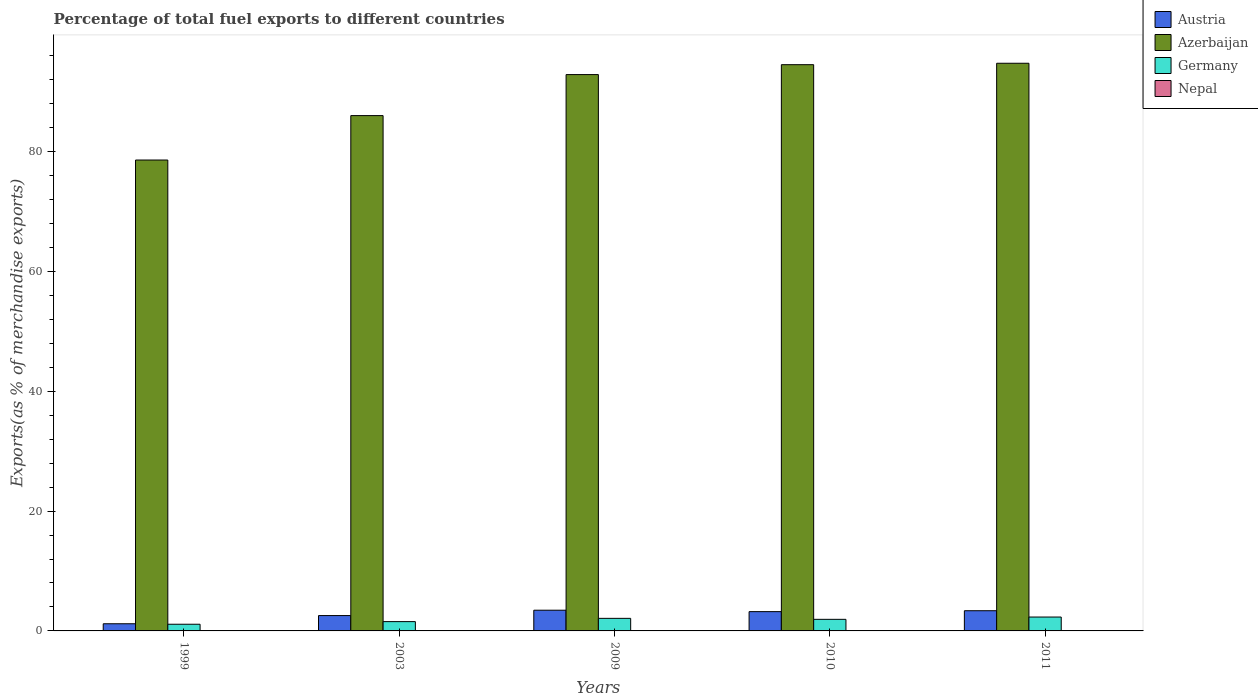Are the number of bars on each tick of the X-axis equal?
Provide a short and direct response. Yes. How many bars are there on the 3rd tick from the left?
Your answer should be compact. 4. How many bars are there on the 4th tick from the right?
Provide a short and direct response. 4. What is the label of the 5th group of bars from the left?
Give a very brief answer. 2011. What is the percentage of exports to different countries in Nepal in 2009?
Offer a very short reply. 0. Across all years, what is the maximum percentage of exports to different countries in Azerbaijan?
Your answer should be very brief. 94.75. Across all years, what is the minimum percentage of exports to different countries in Germany?
Keep it short and to the point. 1.12. In which year was the percentage of exports to different countries in Germany minimum?
Ensure brevity in your answer.  1999. What is the total percentage of exports to different countries in Germany in the graph?
Your answer should be compact. 9.02. What is the difference between the percentage of exports to different countries in Austria in 2003 and that in 2009?
Make the answer very short. -0.89. What is the difference between the percentage of exports to different countries in Germany in 2011 and the percentage of exports to different countries in Azerbaijan in 1999?
Offer a terse response. -76.28. What is the average percentage of exports to different countries in Germany per year?
Provide a succinct answer. 1.8. In the year 2003, what is the difference between the percentage of exports to different countries in Nepal and percentage of exports to different countries in Austria?
Keep it short and to the point. -2.56. In how many years, is the percentage of exports to different countries in Nepal greater than 32 %?
Your answer should be compact. 0. What is the ratio of the percentage of exports to different countries in Nepal in 2003 to that in 2011?
Provide a succinct answer. 690.53. Is the percentage of exports to different countries in Germany in 2009 less than that in 2010?
Provide a short and direct response. No. What is the difference between the highest and the second highest percentage of exports to different countries in Austria?
Your response must be concise. 0.09. What is the difference between the highest and the lowest percentage of exports to different countries in Austria?
Ensure brevity in your answer.  2.26. Is it the case that in every year, the sum of the percentage of exports to different countries in Austria and percentage of exports to different countries in Germany is greater than the sum of percentage of exports to different countries in Nepal and percentage of exports to different countries in Azerbaijan?
Make the answer very short. No. What does the 1st bar from the left in 1999 represents?
Give a very brief answer. Austria. How many years are there in the graph?
Provide a short and direct response. 5. What is the difference between two consecutive major ticks on the Y-axis?
Your answer should be compact. 20. Are the values on the major ticks of Y-axis written in scientific E-notation?
Provide a short and direct response. No. Where does the legend appear in the graph?
Offer a terse response. Top right. How are the legend labels stacked?
Keep it short and to the point. Vertical. What is the title of the graph?
Keep it short and to the point. Percentage of total fuel exports to different countries. What is the label or title of the Y-axis?
Your answer should be compact. Exports(as % of merchandise exports). What is the Exports(as % of merchandise exports) of Austria in 1999?
Ensure brevity in your answer.  1.19. What is the Exports(as % of merchandise exports) of Azerbaijan in 1999?
Offer a terse response. 78.6. What is the Exports(as % of merchandise exports) of Germany in 1999?
Your answer should be compact. 1.12. What is the Exports(as % of merchandise exports) of Nepal in 1999?
Your response must be concise. 0. What is the Exports(as % of merchandise exports) of Austria in 2003?
Keep it short and to the point. 2.56. What is the Exports(as % of merchandise exports) in Azerbaijan in 2003?
Your response must be concise. 86.01. What is the Exports(as % of merchandise exports) in Germany in 2003?
Your answer should be compact. 1.55. What is the Exports(as % of merchandise exports) of Nepal in 2003?
Give a very brief answer. 0. What is the Exports(as % of merchandise exports) in Austria in 2009?
Your answer should be very brief. 3.46. What is the Exports(as % of merchandise exports) in Azerbaijan in 2009?
Your answer should be very brief. 92.86. What is the Exports(as % of merchandise exports) of Germany in 2009?
Offer a terse response. 2.1. What is the Exports(as % of merchandise exports) in Nepal in 2009?
Your answer should be compact. 0. What is the Exports(as % of merchandise exports) in Austria in 2010?
Your response must be concise. 3.22. What is the Exports(as % of merchandise exports) in Azerbaijan in 2010?
Ensure brevity in your answer.  94.51. What is the Exports(as % of merchandise exports) of Germany in 2010?
Ensure brevity in your answer.  1.93. What is the Exports(as % of merchandise exports) of Nepal in 2010?
Keep it short and to the point. 4.5184108995034e-5. What is the Exports(as % of merchandise exports) of Austria in 2011?
Your answer should be very brief. 3.37. What is the Exports(as % of merchandise exports) of Azerbaijan in 2011?
Offer a very short reply. 94.75. What is the Exports(as % of merchandise exports) of Germany in 2011?
Give a very brief answer. 2.32. What is the Exports(as % of merchandise exports) in Nepal in 2011?
Your response must be concise. 5.17830048737702e-6. Across all years, what is the maximum Exports(as % of merchandise exports) of Austria?
Keep it short and to the point. 3.46. Across all years, what is the maximum Exports(as % of merchandise exports) in Azerbaijan?
Keep it short and to the point. 94.75. Across all years, what is the maximum Exports(as % of merchandise exports) in Germany?
Offer a terse response. 2.32. Across all years, what is the maximum Exports(as % of merchandise exports) of Nepal?
Offer a very short reply. 0. Across all years, what is the minimum Exports(as % of merchandise exports) in Austria?
Your answer should be very brief. 1.19. Across all years, what is the minimum Exports(as % of merchandise exports) in Azerbaijan?
Provide a short and direct response. 78.6. Across all years, what is the minimum Exports(as % of merchandise exports) in Germany?
Your answer should be very brief. 1.12. Across all years, what is the minimum Exports(as % of merchandise exports) of Nepal?
Make the answer very short. 5.17830048737702e-6. What is the total Exports(as % of merchandise exports) in Austria in the graph?
Your answer should be very brief. 13.8. What is the total Exports(as % of merchandise exports) of Azerbaijan in the graph?
Give a very brief answer. 446.72. What is the total Exports(as % of merchandise exports) of Germany in the graph?
Your answer should be very brief. 9.02. What is the total Exports(as % of merchandise exports) in Nepal in the graph?
Your answer should be compact. 0.01. What is the difference between the Exports(as % of merchandise exports) in Austria in 1999 and that in 2003?
Offer a terse response. -1.37. What is the difference between the Exports(as % of merchandise exports) in Azerbaijan in 1999 and that in 2003?
Your answer should be very brief. -7.41. What is the difference between the Exports(as % of merchandise exports) of Germany in 1999 and that in 2003?
Offer a terse response. -0.44. What is the difference between the Exports(as % of merchandise exports) of Nepal in 1999 and that in 2003?
Your answer should be very brief. -0. What is the difference between the Exports(as % of merchandise exports) in Austria in 1999 and that in 2009?
Your answer should be compact. -2.26. What is the difference between the Exports(as % of merchandise exports) of Azerbaijan in 1999 and that in 2009?
Offer a terse response. -14.26. What is the difference between the Exports(as % of merchandise exports) in Germany in 1999 and that in 2009?
Provide a succinct answer. -0.98. What is the difference between the Exports(as % of merchandise exports) of Austria in 1999 and that in 2010?
Offer a very short reply. -2.02. What is the difference between the Exports(as % of merchandise exports) in Azerbaijan in 1999 and that in 2010?
Your response must be concise. -15.91. What is the difference between the Exports(as % of merchandise exports) in Germany in 1999 and that in 2010?
Ensure brevity in your answer.  -0.82. What is the difference between the Exports(as % of merchandise exports) of Nepal in 1999 and that in 2010?
Provide a succinct answer. 0. What is the difference between the Exports(as % of merchandise exports) in Austria in 1999 and that in 2011?
Your response must be concise. -2.18. What is the difference between the Exports(as % of merchandise exports) in Azerbaijan in 1999 and that in 2011?
Offer a very short reply. -16.15. What is the difference between the Exports(as % of merchandise exports) in Germany in 1999 and that in 2011?
Provide a short and direct response. -1.2. What is the difference between the Exports(as % of merchandise exports) in Nepal in 1999 and that in 2011?
Your answer should be compact. 0. What is the difference between the Exports(as % of merchandise exports) in Austria in 2003 and that in 2009?
Provide a short and direct response. -0.89. What is the difference between the Exports(as % of merchandise exports) in Azerbaijan in 2003 and that in 2009?
Provide a short and direct response. -6.85. What is the difference between the Exports(as % of merchandise exports) in Germany in 2003 and that in 2009?
Give a very brief answer. -0.54. What is the difference between the Exports(as % of merchandise exports) of Nepal in 2003 and that in 2009?
Make the answer very short. 0. What is the difference between the Exports(as % of merchandise exports) of Austria in 2003 and that in 2010?
Offer a terse response. -0.66. What is the difference between the Exports(as % of merchandise exports) in Azerbaijan in 2003 and that in 2010?
Provide a succinct answer. -8.5. What is the difference between the Exports(as % of merchandise exports) in Germany in 2003 and that in 2010?
Your response must be concise. -0.38. What is the difference between the Exports(as % of merchandise exports) in Nepal in 2003 and that in 2010?
Your response must be concise. 0. What is the difference between the Exports(as % of merchandise exports) of Austria in 2003 and that in 2011?
Your response must be concise. -0.81. What is the difference between the Exports(as % of merchandise exports) in Azerbaijan in 2003 and that in 2011?
Your answer should be very brief. -8.74. What is the difference between the Exports(as % of merchandise exports) of Germany in 2003 and that in 2011?
Make the answer very short. -0.76. What is the difference between the Exports(as % of merchandise exports) in Nepal in 2003 and that in 2011?
Make the answer very short. 0. What is the difference between the Exports(as % of merchandise exports) of Austria in 2009 and that in 2010?
Your answer should be compact. 0.24. What is the difference between the Exports(as % of merchandise exports) in Azerbaijan in 2009 and that in 2010?
Provide a succinct answer. -1.65. What is the difference between the Exports(as % of merchandise exports) in Germany in 2009 and that in 2010?
Provide a succinct answer. 0.16. What is the difference between the Exports(as % of merchandise exports) of Nepal in 2009 and that in 2010?
Provide a succinct answer. 0. What is the difference between the Exports(as % of merchandise exports) of Austria in 2009 and that in 2011?
Provide a short and direct response. 0.09. What is the difference between the Exports(as % of merchandise exports) in Azerbaijan in 2009 and that in 2011?
Give a very brief answer. -1.89. What is the difference between the Exports(as % of merchandise exports) in Germany in 2009 and that in 2011?
Make the answer very short. -0.22. What is the difference between the Exports(as % of merchandise exports) of Nepal in 2009 and that in 2011?
Make the answer very short. 0. What is the difference between the Exports(as % of merchandise exports) of Austria in 2010 and that in 2011?
Your response must be concise. -0.15. What is the difference between the Exports(as % of merchandise exports) of Azerbaijan in 2010 and that in 2011?
Provide a short and direct response. -0.24. What is the difference between the Exports(as % of merchandise exports) in Germany in 2010 and that in 2011?
Provide a short and direct response. -0.38. What is the difference between the Exports(as % of merchandise exports) of Nepal in 2010 and that in 2011?
Provide a succinct answer. 0. What is the difference between the Exports(as % of merchandise exports) of Austria in 1999 and the Exports(as % of merchandise exports) of Azerbaijan in 2003?
Your answer should be very brief. -84.82. What is the difference between the Exports(as % of merchandise exports) in Austria in 1999 and the Exports(as % of merchandise exports) in Germany in 2003?
Give a very brief answer. -0.36. What is the difference between the Exports(as % of merchandise exports) of Austria in 1999 and the Exports(as % of merchandise exports) of Nepal in 2003?
Provide a succinct answer. 1.19. What is the difference between the Exports(as % of merchandise exports) of Azerbaijan in 1999 and the Exports(as % of merchandise exports) of Germany in 2003?
Provide a short and direct response. 77.04. What is the difference between the Exports(as % of merchandise exports) of Azerbaijan in 1999 and the Exports(as % of merchandise exports) of Nepal in 2003?
Provide a short and direct response. 78.59. What is the difference between the Exports(as % of merchandise exports) in Germany in 1999 and the Exports(as % of merchandise exports) in Nepal in 2003?
Your answer should be very brief. 1.11. What is the difference between the Exports(as % of merchandise exports) in Austria in 1999 and the Exports(as % of merchandise exports) in Azerbaijan in 2009?
Your answer should be compact. -91.66. What is the difference between the Exports(as % of merchandise exports) in Austria in 1999 and the Exports(as % of merchandise exports) in Germany in 2009?
Ensure brevity in your answer.  -0.9. What is the difference between the Exports(as % of merchandise exports) in Austria in 1999 and the Exports(as % of merchandise exports) in Nepal in 2009?
Keep it short and to the point. 1.19. What is the difference between the Exports(as % of merchandise exports) of Azerbaijan in 1999 and the Exports(as % of merchandise exports) of Germany in 2009?
Ensure brevity in your answer.  76.5. What is the difference between the Exports(as % of merchandise exports) in Azerbaijan in 1999 and the Exports(as % of merchandise exports) in Nepal in 2009?
Offer a terse response. 78.59. What is the difference between the Exports(as % of merchandise exports) in Germany in 1999 and the Exports(as % of merchandise exports) in Nepal in 2009?
Your answer should be compact. 1.11. What is the difference between the Exports(as % of merchandise exports) in Austria in 1999 and the Exports(as % of merchandise exports) in Azerbaijan in 2010?
Ensure brevity in your answer.  -93.32. What is the difference between the Exports(as % of merchandise exports) in Austria in 1999 and the Exports(as % of merchandise exports) in Germany in 2010?
Ensure brevity in your answer.  -0.74. What is the difference between the Exports(as % of merchandise exports) of Austria in 1999 and the Exports(as % of merchandise exports) of Nepal in 2010?
Ensure brevity in your answer.  1.19. What is the difference between the Exports(as % of merchandise exports) in Azerbaijan in 1999 and the Exports(as % of merchandise exports) in Germany in 2010?
Provide a short and direct response. 76.66. What is the difference between the Exports(as % of merchandise exports) in Azerbaijan in 1999 and the Exports(as % of merchandise exports) in Nepal in 2010?
Your answer should be very brief. 78.6. What is the difference between the Exports(as % of merchandise exports) in Germany in 1999 and the Exports(as % of merchandise exports) in Nepal in 2010?
Provide a short and direct response. 1.12. What is the difference between the Exports(as % of merchandise exports) in Austria in 1999 and the Exports(as % of merchandise exports) in Azerbaijan in 2011?
Make the answer very short. -93.55. What is the difference between the Exports(as % of merchandise exports) in Austria in 1999 and the Exports(as % of merchandise exports) in Germany in 2011?
Offer a terse response. -1.12. What is the difference between the Exports(as % of merchandise exports) of Austria in 1999 and the Exports(as % of merchandise exports) of Nepal in 2011?
Give a very brief answer. 1.19. What is the difference between the Exports(as % of merchandise exports) in Azerbaijan in 1999 and the Exports(as % of merchandise exports) in Germany in 2011?
Offer a very short reply. 76.28. What is the difference between the Exports(as % of merchandise exports) in Azerbaijan in 1999 and the Exports(as % of merchandise exports) in Nepal in 2011?
Provide a short and direct response. 78.6. What is the difference between the Exports(as % of merchandise exports) in Germany in 1999 and the Exports(as % of merchandise exports) in Nepal in 2011?
Keep it short and to the point. 1.12. What is the difference between the Exports(as % of merchandise exports) in Austria in 2003 and the Exports(as % of merchandise exports) in Azerbaijan in 2009?
Provide a succinct answer. -90.29. What is the difference between the Exports(as % of merchandise exports) in Austria in 2003 and the Exports(as % of merchandise exports) in Germany in 2009?
Offer a terse response. 0.46. What is the difference between the Exports(as % of merchandise exports) of Austria in 2003 and the Exports(as % of merchandise exports) of Nepal in 2009?
Your answer should be very brief. 2.56. What is the difference between the Exports(as % of merchandise exports) in Azerbaijan in 2003 and the Exports(as % of merchandise exports) in Germany in 2009?
Provide a succinct answer. 83.91. What is the difference between the Exports(as % of merchandise exports) of Azerbaijan in 2003 and the Exports(as % of merchandise exports) of Nepal in 2009?
Make the answer very short. 86.01. What is the difference between the Exports(as % of merchandise exports) of Germany in 2003 and the Exports(as % of merchandise exports) of Nepal in 2009?
Provide a short and direct response. 1.55. What is the difference between the Exports(as % of merchandise exports) of Austria in 2003 and the Exports(as % of merchandise exports) of Azerbaijan in 2010?
Provide a short and direct response. -91.95. What is the difference between the Exports(as % of merchandise exports) in Austria in 2003 and the Exports(as % of merchandise exports) in Germany in 2010?
Ensure brevity in your answer.  0.63. What is the difference between the Exports(as % of merchandise exports) in Austria in 2003 and the Exports(as % of merchandise exports) in Nepal in 2010?
Your answer should be very brief. 2.56. What is the difference between the Exports(as % of merchandise exports) of Azerbaijan in 2003 and the Exports(as % of merchandise exports) of Germany in 2010?
Provide a short and direct response. 84.08. What is the difference between the Exports(as % of merchandise exports) in Azerbaijan in 2003 and the Exports(as % of merchandise exports) in Nepal in 2010?
Offer a terse response. 86.01. What is the difference between the Exports(as % of merchandise exports) of Germany in 2003 and the Exports(as % of merchandise exports) of Nepal in 2010?
Your answer should be compact. 1.55. What is the difference between the Exports(as % of merchandise exports) in Austria in 2003 and the Exports(as % of merchandise exports) in Azerbaijan in 2011?
Provide a short and direct response. -92.19. What is the difference between the Exports(as % of merchandise exports) of Austria in 2003 and the Exports(as % of merchandise exports) of Germany in 2011?
Provide a short and direct response. 0.25. What is the difference between the Exports(as % of merchandise exports) in Austria in 2003 and the Exports(as % of merchandise exports) in Nepal in 2011?
Provide a succinct answer. 2.56. What is the difference between the Exports(as % of merchandise exports) of Azerbaijan in 2003 and the Exports(as % of merchandise exports) of Germany in 2011?
Provide a succinct answer. 83.69. What is the difference between the Exports(as % of merchandise exports) of Azerbaijan in 2003 and the Exports(as % of merchandise exports) of Nepal in 2011?
Provide a succinct answer. 86.01. What is the difference between the Exports(as % of merchandise exports) of Germany in 2003 and the Exports(as % of merchandise exports) of Nepal in 2011?
Give a very brief answer. 1.55. What is the difference between the Exports(as % of merchandise exports) of Austria in 2009 and the Exports(as % of merchandise exports) of Azerbaijan in 2010?
Offer a very short reply. -91.05. What is the difference between the Exports(as % of merchandise exports) in Austria in 2009 and the Exports(as % of merchandise exports) in Germany in 2010?
Offer a terse response. 1.52. What is the difference between the Exports(as % of merchandise exports) of Austria in 2009 and the Exports(as % of merchandise exports) of Nepal in 2010?
Provide a short and direct response. 3.46. What is the difference between the Exports(as % of merchandise exports) of Azerbaijan in 2009 and the Exports(as % of merchandise exports) of Germany in 2010?
Ensure brevity in your answer.  90.92. What is the difference between the Exports(as % of merchandise exports) of Azerbaijan in 2009 and the Exports(as % of merchandise exports) of Nepal in 2010?
Offer a very short reply. 92.86. What is the difference between the Exports(as % of merchandise exports) in Germany in 2009 and the Exports(as % of merchandise exports) in Nepal in 2010?
Your answer should be very brief. 2.1. What is the difference between the Exports(as % of merchandise exports) of Austria in 2009 and the Exports(as % of merchandise exports) of Azerbaijan in 2011?
Keep it short and to the point. -91.29. What is the difference between the Exports(as % of merchandise exports) in Austria in 2009 and the Exports(as % of merchandise exports) in Germany in 2011?
Ensure brevity in your answer.  1.14. What is the difference between the Exports(as % of merchandise exports) in Austria in 2009 and the Exports(as % of merchandise exports) in Nepal in 2011?
Your answer should be very brief. 3.46. What is the difference between the Exports(as % of merchandise exports) in Azerbaijan in 2009 and the Exports(as % of merchandise exports) in Germany in 2011?
Offer a very short reply. 90.54. What is the difference between the Exports(as % of merchandise exports) in Azerbaijan in 2009 and the Exports(as % of merchandise exports) in Nepal in 2011?
Your response must be concise. 92.86. What is the difference between the Exports(as % of merchandise exports) of Germany in 2009 and the Exports(as % of merchandise exports) of Nepal in 2011?
Make the answer very short. 2.1. What is the difference between the Exports(as % of merchandise exports) of Austria in 2010 and the Exports(as % of merchandise exports) of Azerbaijan in 2011?
Your response must be concise. -91.53. What is the difference between the Exports(as % of merchandise exports) of Austria in 2010 and the Exports(as % of merchandise exports) of Germany in 2011?
Keep it short and to the point. 0.9. What is the difference between the Exports(as % of merchandise exports) in Austria in 2010 and the Exports(as % of merchandise exports) in Nepal in 2011?
Your answer should be compact. 3.22. What is the difference between the Exports(as % of merchandise exports) in Azerbaijan in 2010 and the Exports(as % of merchandise exports) in Germany in 2011?
Offer a very short reply. 92.19. What is the difference between the Exports(as % of merchandise exports) of Azerbaijan in 2010 and the Exports(as % of merchandise exports) of Nepal in 2011?
Provide a succinct answer. 94.51. What is the difference between the Exports(as % of merchandise exports) of Germany in 2010 and the Exports(as % of merchandise exports) of Nepal in 2011?
Provide a short and direct response. 1.93. What is the average Exports(as % of merchandise exports) in Austria per year?
Ensure brevity in your answer.  2.76. What is the average Exports(as % of merchandise exports) in Azerbaijan per year?
Your answer should be compact. 89.34. What is the average Exports(as % of merchandise exports) in Germany per year?
Offer a terse response. 1.8. What is the average Exports(as % of merchandise exports) of Nepal per year?
Your answer should be very brief. 0. In the year 1999, what is the difference between the Exports(as % of merchandise exports) of Austria and Exports(as % of merchandise exports) of Azerbaijan?
Make the answer very short. -77.4. In the year 1999, what is the difference between the Exports(as % of merchandise exports) in Austria and Exports(as % of merchandise exports) in Germany?
Offer a terse response. 0.08. In the year 1999, what is the difference between the Exports(as % of merchandise exports) in Austria and Exports(as % of merchandise exports) in Nepal?
Provide a succinct answer. 1.19. In the year 1999, what is the difference between the Exports(as % of merchandise exports) of Azerbaijan and Exports(as % of merchandise exports) of Germany?
Offer a very short reply. 77.48. In the year 1999, what is the difference between the Exports(as % of merchandise exports) in Azerbaijan and Exports(as % of merchandise exports) in Nepal?
Your answer should be compact. 78.59. In the year 1999, what is the difference between the Exports(as % of merchandise exports) in Germany and Exports(as % of merchandise exports) in Nepal?
Offer a very short reply. 1.11. In the year 2003, what is the difference between the Exports(as % of merchandise exports) in Austria and Exports(as % of merchandise exports) in Azerbaijan?
Ensure brevity in your answer.  -83.45. In the year 2003, what is the difference between the Exports(as % of merchandise exports) of Austria and Exports(as % of merchandise exports) of Germany?
Give a very brief answer. 1.01. In the year 2003, what is the difference between the Exports(as % of merchandise exports) of Austria and Exports(as % of merchandise exports) of Nepal?
Give a very brief answer. 2.56. In the year 2003, what is the difference between the Exports(as % of merchandise exports) in Azerbaijan and Exports(as % of merchandise exports) in Germany?
Your answer should be compact. 84.46. In the year 2003, what is the difference between the Exports(as % of merchandise exports) in Azerbaijan and Exports(as % of merchandise exports) in Nepal?
Your answer should be very brief. 86.01. In the year 2003, what is the difference between the Exports(as % of merchandise exports) in Germany and Exports(as % of merchandise exports) in Nepal?
Ensure brevity in your answer.  1.55. In the year 2009, what is the difference between the Exports(as % of merchandise exports) in Austria and Exports(as % of merchandise exports) in Azerbaijan?
Provide a succinct answer. -89.4. In the year 2009, what is the difference between the Exports(as % of merchandise exports) of Austria and Exports(as % of merchandise exports) of Germany?
Provide a succinct answer. 1.36. In the year 2009, what is the difference between the Exports(as % of merchandise exports) of Austria and Exports(as % of merchandise exports) of Nepal?
Your answer should be very brief. 3.45. In the year 2009, what is the difference between the Exports(as % of merchandise exports) in Azerbaijan and Exports(as % of merchandise exports) in Germany?
Offer a very short reply. 90.76. In the year 2009, what is the difference between the Exports(as % of merchandise exports) in Azerbaijan and Exports(as % of merchandise exports) in Nepal?
Your answer should be very brief. 92.86. In the year 2009, what is the difference between the Exports(as % of merchandise exports) of Germany and Exports(as % of merchandise exports) of Nepal?
Provide a short and direct response. 2.1. In the year 2010, what is the difference between the Exports(as % of merchandise exports) in Austria and Exports(as % of merchandise exports) in Azerbaijan?
Make the answer very short. -91.29. In the year 2010, what is the difference between the Exports(as % of merchandise exports) in Austria and Exports(as % of merchandise exports) in Germany?
Provide a short and direct response. 1.28. In the year 2010, what is the difference between the Exports(as % of merchandise exports) in Austria and Exports(as % of merchandise exports) in Nepal?
Make the answer very short. 3.22. In the year 2010, what is the difference between the Exports(as % of merchandise exports) of Azerbaijan and Exports(as % of merchandise exports) of Germany?
Your answer should be very brief. 92.58. In the year 2010, what is the difference between the Exports(as % of merchandise exports) in Azerbaijan and Exports(as % of merchandise exports) in Nepal?
Keep it short and to the point. 94.51. In the year 2010, what is the difference between the Exports(as % of merchandise exports) in Germany and Exports(as % of merchandise exports) in Nepal?
Make the answer very short. 1.93. In the year 2011, what is the difference between the Exports(as % of merchandise exports) in Austria and Exports(as % of merchandise exports) in Azerbaijan?
Ensure brevity in your answer.  -91.38. In the year 2011, what is the difference between the Exports(as % of merchandise exports) in Austria and Exports(as % of merchandise exports) in Germany?
Keep it short and to the point. 1.05. In the year 2011, what is the difference between the Exports(as % of merchandise exports) in Austria and Exports(as % of merchandise exports) in Nepal?
Your answer should be compact. 3.37. In the year 2011, what is the difference between the Exports(as % of merchandise exports) of Azerbaijan and Exports(as % of merchandise exports) of Germany?
Provide a succinct answer. 92.43. In the year 2011, what is the difference between the Exports(as % of merchandise exports) of Azerbaijan and Exports(as % of merchandise exports) of Nepal?
Make the answer very short. 94.75. In the year 2011, what is the difference between the Exports(as % of merchandise exports) of Germany and Exports(as % of merchandise exports) of Nepal?
Make the answer very short. 2.32. What is the ratio of the Exports(as % of merchandise exports) in Austria in 1999 to that in 2003?
Provide a succinct answer. 0.47. What is the ratio of the Exports(as % of merchandise exports) of Azerbaijan in 1999 to that in 2003?
Your answer should be very brief. 0.91. What is the ratio of the Exports(as % of merchandise exports) of Germany in 1999 to that in 2003?
Your answer should be compact. 0.72. What is the ratio of the Exports(as % of merchandise exports) of Nepal in 1999 to that in 2003?
Offer a terse response. 0.6. What is the ratio of the Exports(as % of merchandise exports) in Austria in 1999 to that in 2009?
Your answer should be very brief. 0.35. What is the ratio of the Exports(as % of merchandise exports) of Azerbaijan in 1999 to that in 2009?
Your answer should be compact. 0.85. What is the ratio of the Exports(as % of merchandise exports) in Germany in 1999 to that in 2009?
Your answer should be very brief. 0.53. What is the ratio of the Exports(as % of merchandise exports) of Nepal in 1999 to that in 2009?
Offer a terse response. 1.28. What is the ratio of the Exports(as % of merchandise exports) of Austria in 1999 to that in 2010?
Provide a short and direct response. 0.37. What is the ratio of the Exports(as % of merchandise exports) in Azerbaijan in 1999 to that in 2010?
Keep it short and to the point. 0.83. What is the ratio of the Exports(as % of merchandise exports) in Germany in 1999 to that in 2010?
Your answer should be very brief. 0.58. What is the ratio of the Exports(as % of merchandise exports) of Nepal in 1999 to that in 2010?
Provide a succinct answer. 47.85. What is the ratio of the Exports(as % of merchandise exports) in Austria in 1999 to that in 2011?
Your answer should be compact. 0.35. What is the ratio of the Exports(as % of merchandise exports) in Azerbaijan in 1999 to that in 2011?
Offer a terse response. 0.83. What is the ratio of the Exports(as % of merchandise exports) in Germany in 1999 to that in 2011?
Ensure brevity in your answer.  0.48. What is the ratio of the Exports(as % of merchandise exports) in Nepal in 1999 to that in 2011?
Your answer should be very brief. 417.54. What is the ratio of the Exports(as % of merchandise exports) of Austria in 2003 to that in 2009?
Ensure brevity in your answer.  0.74. What is the ratio of the Exports(as % of merchandise exports) in Azerbaijan in 2003 to that in 2009?
Offer a terse response. 0.93. What is the ratio of the Exports(as % of merchandise exports) in Germany in 2003 to that in 2009?
Offer a very short reply. 0.74. What is the ratio of the Exports(as % of merchandise exports) of Nepal in 2003 to that in 2009?
Provide a succinct answer. 2.12. What is the ratio of the Exports(as % of merchandise exports) in Austria in 2003 to that in 2010?
Provide a succinct answer. 0.8. What is the ratio of the Exports(as % of merchandise exports) of Azerbaijan in 2003 to that in 2010?
Your response must be concise. 0.91. What is the ratio of the Exports(as % of merchandise exports) in Germany in 2003 to that in 2010?
Offer a terse response. 0.8. What is the ratio of the Exports(as % of merchandise exports) of Nepal in 2003 to that in 2010?
Your response must be concise. 79.14. What is the ratio of the Exports(as % of merchandise exports) of Austria in 2003 to that in 2011?
Your answer should be very brief. 0.76. What is the ratio of the Exports(as % of merchandise exports) of Azerbaijan in 2003 to that in 2011?
Your answer should be compact. 0.91. What is the ratio of the Exports(as % of merchandise exports) in Germany in 2003 to that in 2011?
Your response must be concise. 0.67. What is the ratio of the Exports(as % of merchandise exports) in Nepal in 2003 to that in 2011?
Offer a terse response. 690.53. What is the ratio of the Exports(as % of merchandise exports) of Austria in 2009 to that in 2010?
Your answer should be very brief. 1.07. What is the ratio of the Exports(as % of merchandise exports) of Azerbaijan in 2009 to that in 2010?
Your answer should be very brief. 0.98. What is the ratio of the Exports(as % of merchandise exports) in Germany in 2009 to that in 2010?
Offer a very short reply. 1.08. What is the ratio of the Exports(as % of merchandise exports) in Nepal in 2009 to that in 2010?
Provide a short and direct response. 37.35. What is the ratio of the Exports(as % of merchandise exports) in Austria in 2009 to that in 2011?
Provide a short and direct response. 1.03. What is the ratio of the Exports(as % of merchandise exports) in Azerbaijan in 2009 to that in 2011?
Provide a succinct answer. 0.98. What is the ratio of the Exports(as % of merchandise exports) in Germany in 2009 to that in 2011?
Provide a succinct answer. 0.91. What is the ratio of the Exports(as % of merchandise exports) of Nepal in 2009 to that in 2011?
Keep it short and to the point. 325.88. What is the ratio of the Exports(as % of merchandise exports) in Austria in 2010 to that in 2011?
Keep it short and to the point. 0.95. What is the ratio of the Exports(as % of merchandise exports) of Azerbaijan in 2010 to that in 2011?
Your response must be concise. 1. What is the ratio of the Exports(as % of merchandise exports) of Germany in 2010 to that in 2011?
Your response must be concise. 0.83. What is the ratio of the Exports(as % of merchandise exports) in Nepal in 2010 to that in 2011?
Your answer should be very brief. 8.73. What is the difference between the highest and the second highest Exports(as % of merchandise exports) in Austria?
Provide a short and direct response. 0.09. What is the difference between the highest and the second highest Exports(as % of merchandise exports) in Azerbaijan?
Provide a succinct answer. 0.24. What is the difference between the highest and the second highest Exports(as % of merchandise exports) of Germany?
Offer a terse response. 0.22. What is the difference between the highest and the second highest Exports(as % of merchandise exports) in Nepal?
Offer a very short reply. 0. What is the difference between the highest and the lowest Exports(as % of merchandise exports) in Austria?
Your answer should be compact. 2.26. What is the difference between the highest and the lowest Exports(as % of merchandise exports) of Azerbaijan?
Your answer should be very brief. 16.15. What is the difference between the highest and the lowest Exports(as % of merchandise exports) of Germany?
Keep it short and to the point. 1.2. What is the difference between the highest and the lowest Exports(as % of merchandise exports) of Nepal?
Offer a very short reply. 0. 